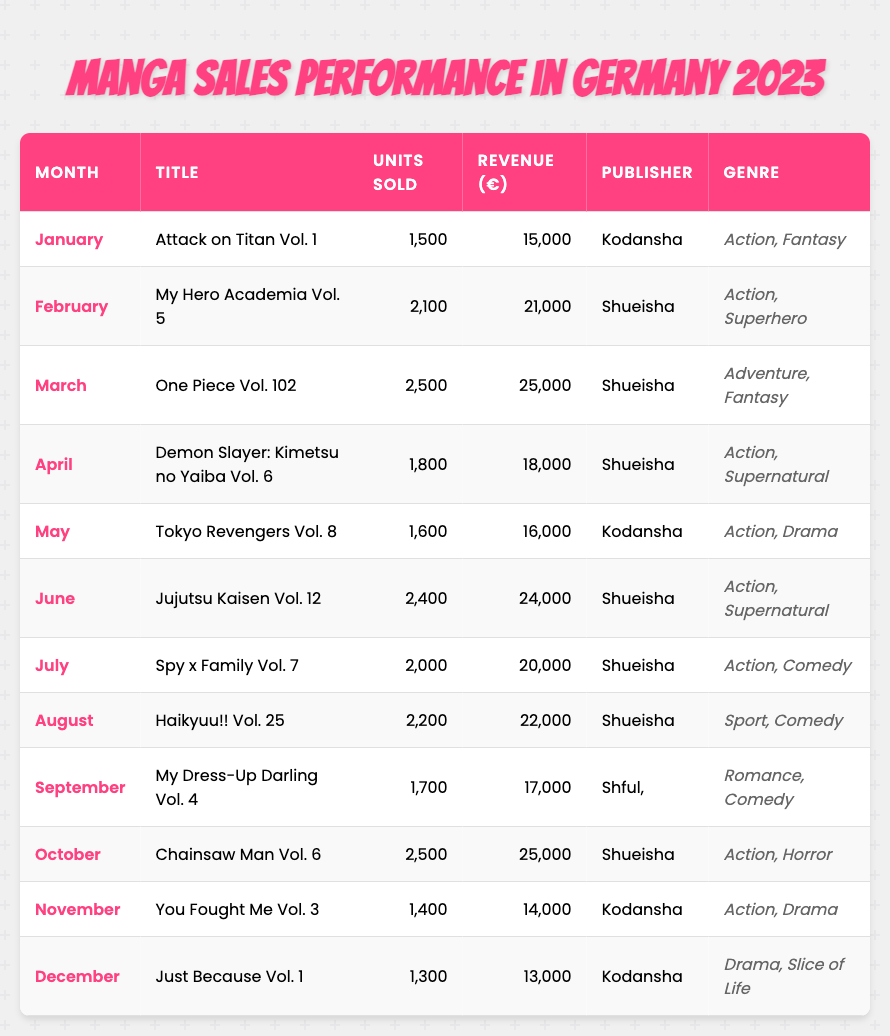What was the best-selling volume in March? In March, the table lists "One Piece Vol. 102" with 2,500 units sold, which is the highest for that month.
Answer: One Piece Vol. 102 How much revenue did "Demon Slayer: Kimetsu no Yaiba Vol. 6" generate? The revenue is listed directly in the table as €18,000.
Answer: €18,000 Which genre was most common among the top three best-selling volumes? The top three best-selling volumes are all in the "Action" genre, including "My Hero Academia," "One Piece," and "Chainsaw Man."
Answer: Action What is the total number of units sold from January to March? Adding the units: 1,500 (January) + 2,100 (February) + 2,500 (March) = 6,100 units sold.
Answer: 6,100 Did "Jujutsu Kaisen Vol. 12" sell more units than "Tokyo Revengers Vol. 8"? "Jujutsu Kaisen Vol. 12" sold 2,400 units, while "Tokyo Revengers Vol. 8" sold 1,600 units. Therefore, it did sell more.
Answer: Yes Which month had the highest revenue, and what was it? The months listed show "One Piece Vol. 102" and "Chainsaw Man Vol. 6," both generating €25,000, which is the highest revenue.
Answer: March and October, €25,000 How many units were sold in November compared to December? In November, 1,400 units were sold, and in December, 1,300 units were sold, indicating November had more sales than December.
Answer: November had more sales What is the average number of units sold from July to September? The units sold are 2,000 (July) + 2,200 (August) + 1,700 (September) = 5,900 total. The average is 5,900 / 3 = 1,966.67, roughly 1,967.
Answer: 1,967 Which publisher released the most volumes in the table? The publisher "Shueisha" appears several times throughout the months (6 times in total), while Kodansha appears 4 times, indicating Shueisha released the most volumes.
Answer: Shueisha Was there a volume that sold less than 1,500 units throughout the year? The lowest units sold are for "Just Because Vol. 1" at 1,300 units, which is less than 1,500.
Answer: Yes 